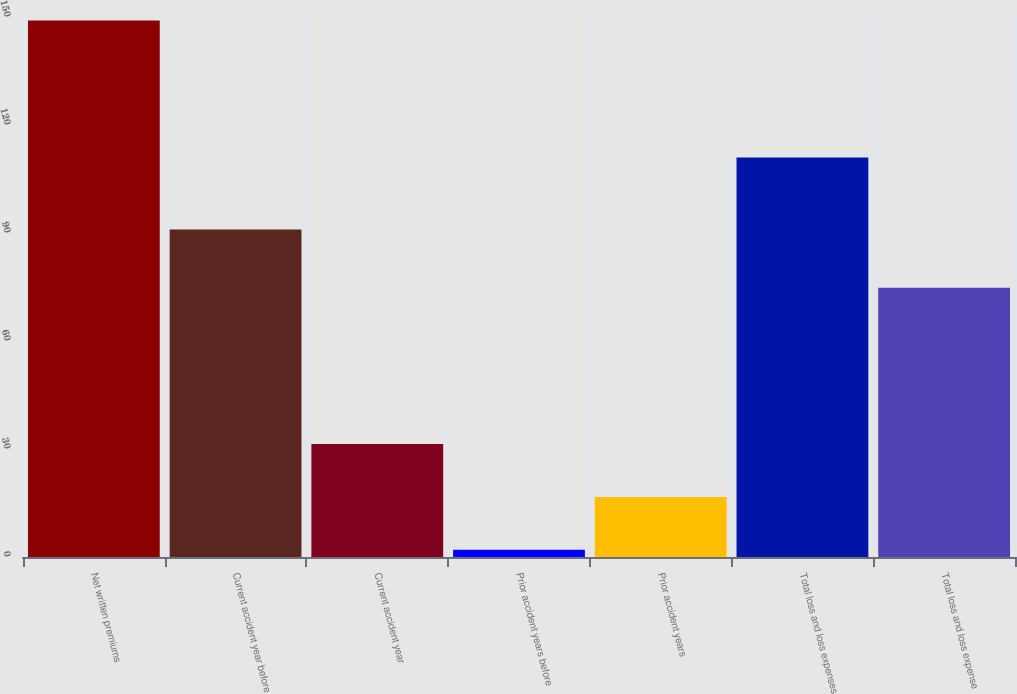Convert chart to OTSL. <chart><loc_0><loc_0><loc_500><loc_500><bar_chart><fcel>Net written premiums<fcel>Current accident year before<fcel>Current accident year<fcel>Prior accident years before<fcel>Prior accident years<fcel>Total loss and loss expenses<fcel>Total loss and loss expense<nl><fcel>149<fcel>91<fcel>31.4<fcel>2<fcel>16.7<fcel>111<fcel>74.8<nl></chart> 